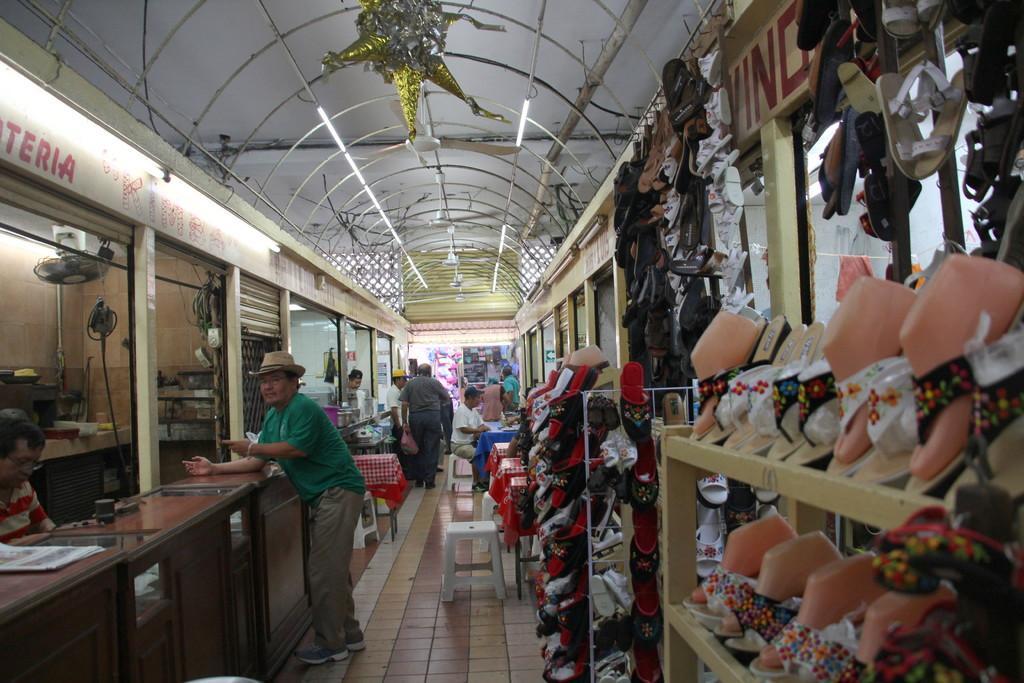Could you give a brief overview of what you see in this image? A picture inside of a footwear store. In this store I can see lights, fan, decorative object, footwear's, racks, tables, grilles, tile floor and objects. Far we can see stories and objects.  